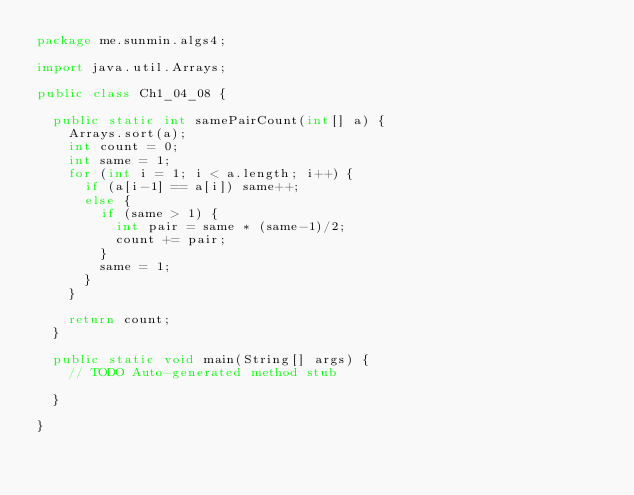<code> <loc_0><loc_0><loc_500><loc_500><_Java_>package me.sunmin.algs4;

import java.util.Arrays;

public class Ch1_04_08 {
	
	public static int samePairCount(int[] a) {
		Arrays.sort(a);
		int count = 0;
		int same = 1;
		for (int i = 1; i < a.length; i++) {
			if (a[i-1] == a[i]) same++;
			else {
				if (same > 1) {
					int pair = same * (same-1)/2;
					count += pair;
				}
				same = 1;
			}
		}
		
		return count;
	}

	public static void main(String[] args) {
		// TODO Auto-generated method stub

	}

}
</code> 